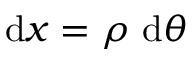Convert formula to latex. <formula><loc_0><loc_0><loc_500><loc_500>d x = \rho d \theta</formula> 